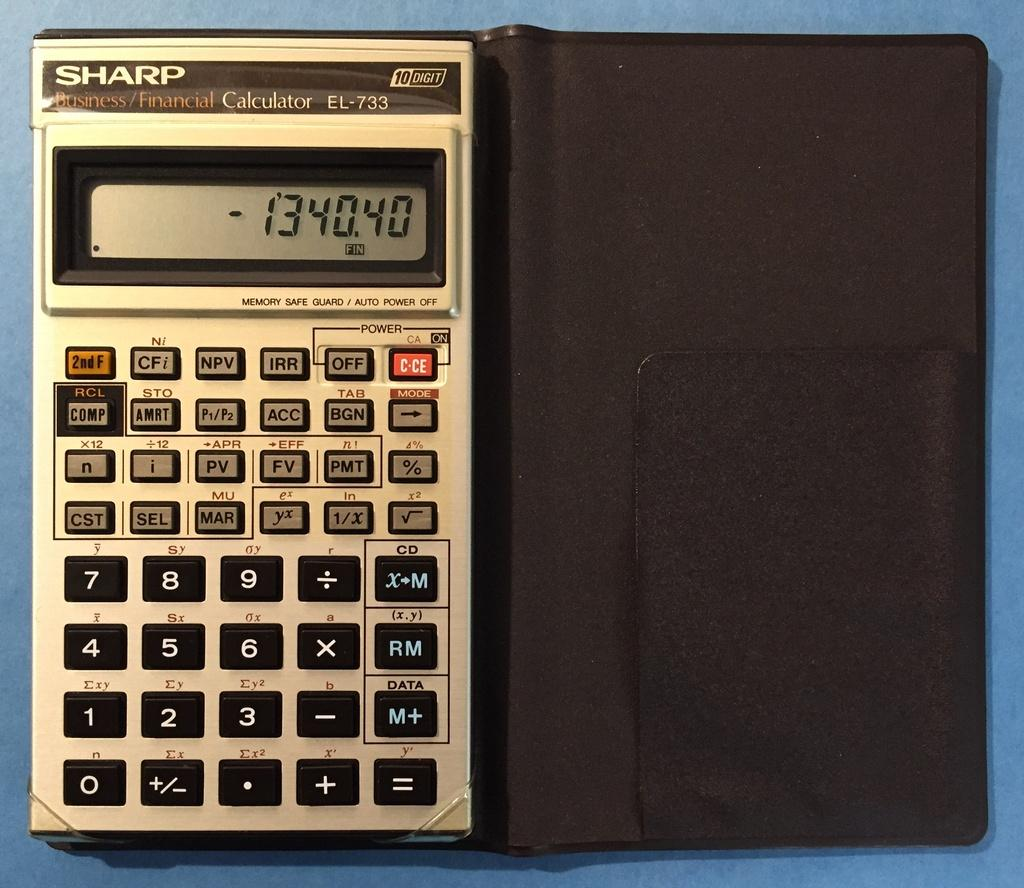<image>
Summarize the visual content of the image. a sharp calculator sits on the dark surface 